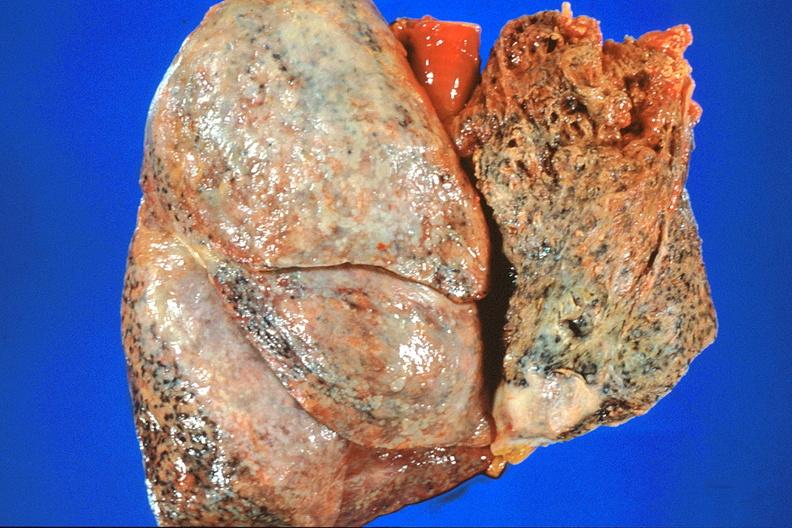s respiratory present?
Answer the question using a single word or phrase. Yes 